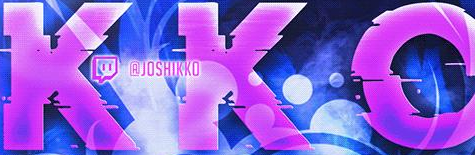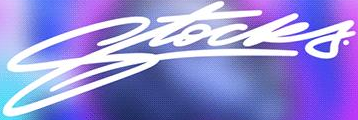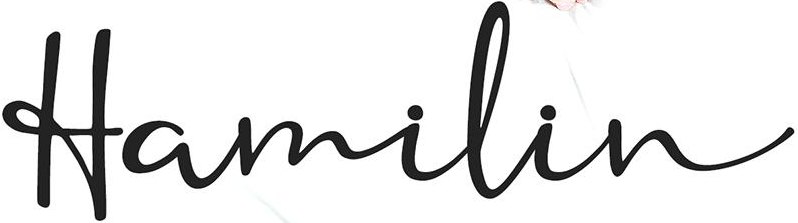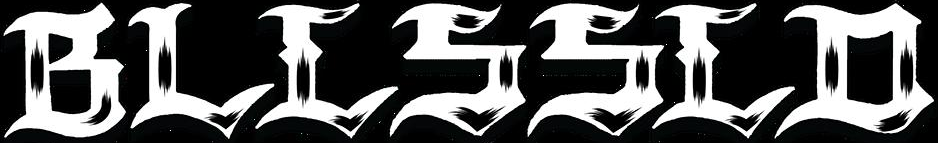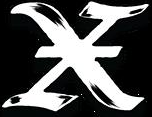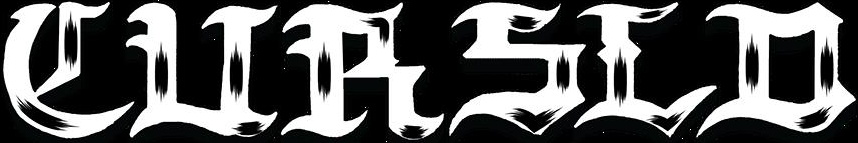Transcribe the words shown in these images in order, separated by a semicolon. KKO; Stocks; Hamilin; BLLSSLD; X; CURSLD 